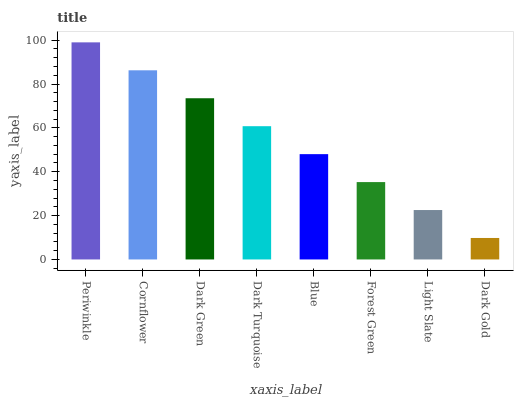Is Dark Gold the minimum?
Answer yes or no. Yes. Is Periwinkle the maximum?
Answer yes or no. Yes. Is Cornflower the minimum?
Answer yes or no. No. Is Cornflower the maximum?
Answer yes or no. No. Is Periwinkle greater than Cornflower?
Answer yes or no. Yes. Is Cornflower less than Periwinkle?
Answer yes or no. Yes. Is Cornflower greater than Periwinkle?
Answer yes or no. No. Is Periwinkle less than Cornflower?
Answer yes or no. No. Is Dark Turquoise the high median?
Answer yes or no. Yes. Is Blue the low median?
Answer yes or no. Yes. Is Periwinkle the high median?
Answer yes or no. No. Is Periwinkle the low median?
Answer yes or no. No. 